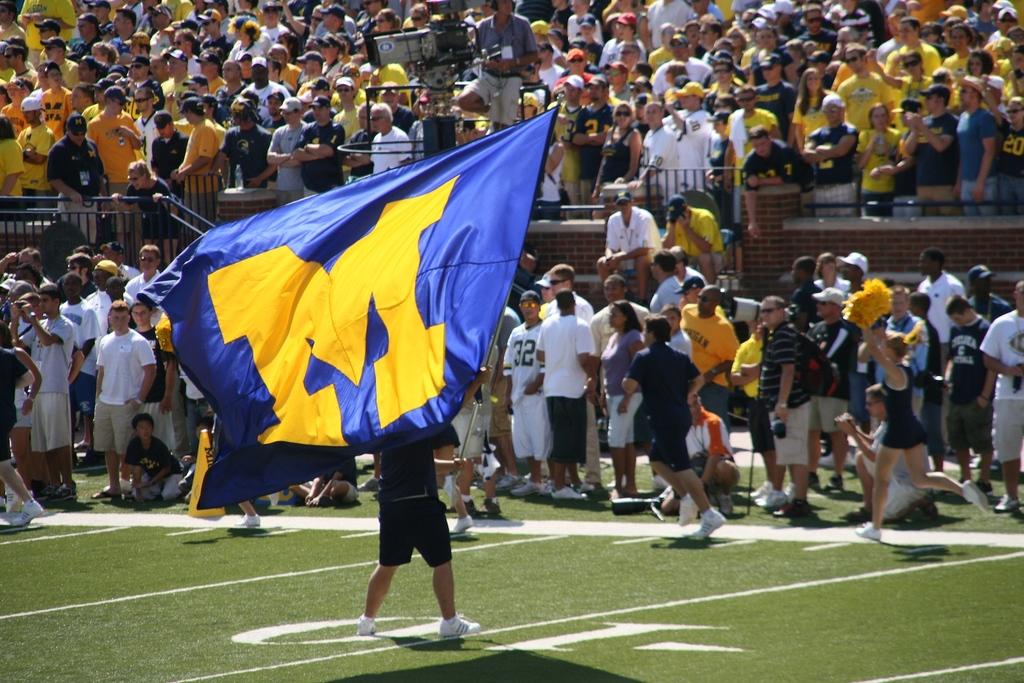What letter is on this banner?
Make the answer very short. M. 